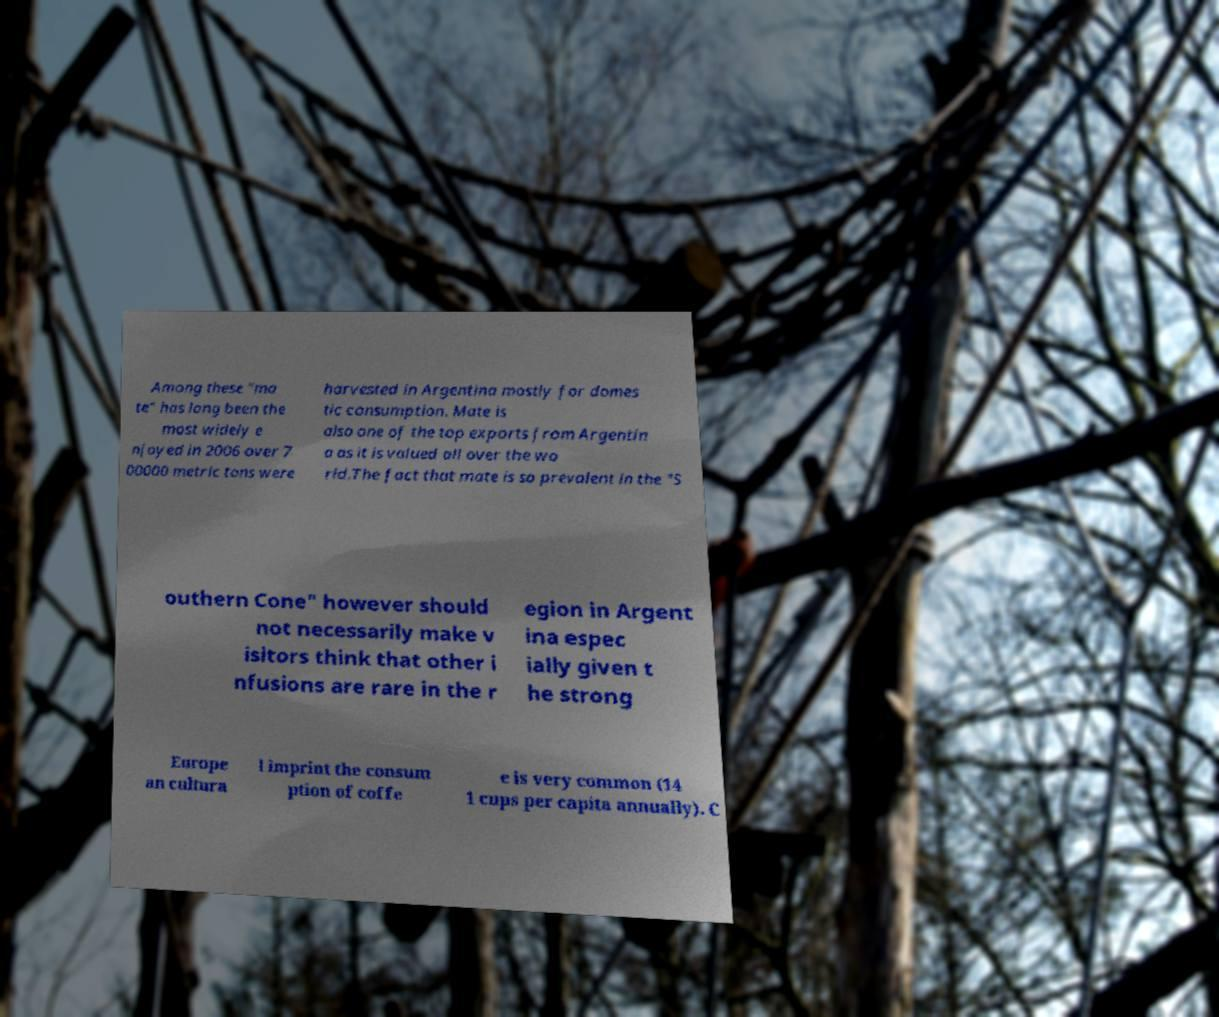I need the written content from this picture converted into text. Can you do that? Among these "ma te" has long been the most widely e njoyed in 2006 over 7 00000 metric tons were harvested in Argentina mostly for domes tic consumption. Mate is also one of the top exports from Argentin a as it is valued all over the wo rld.The fact that mate is so prevalent in the "S outhern Cone" however should not necessarily make v isitors think that other i nfusions are rare in the r egion in Argent ina espec ially given t he strong Europe an cultura l imprint the consum ption of coffe e is very common (14 1 cups per capita annually). C 